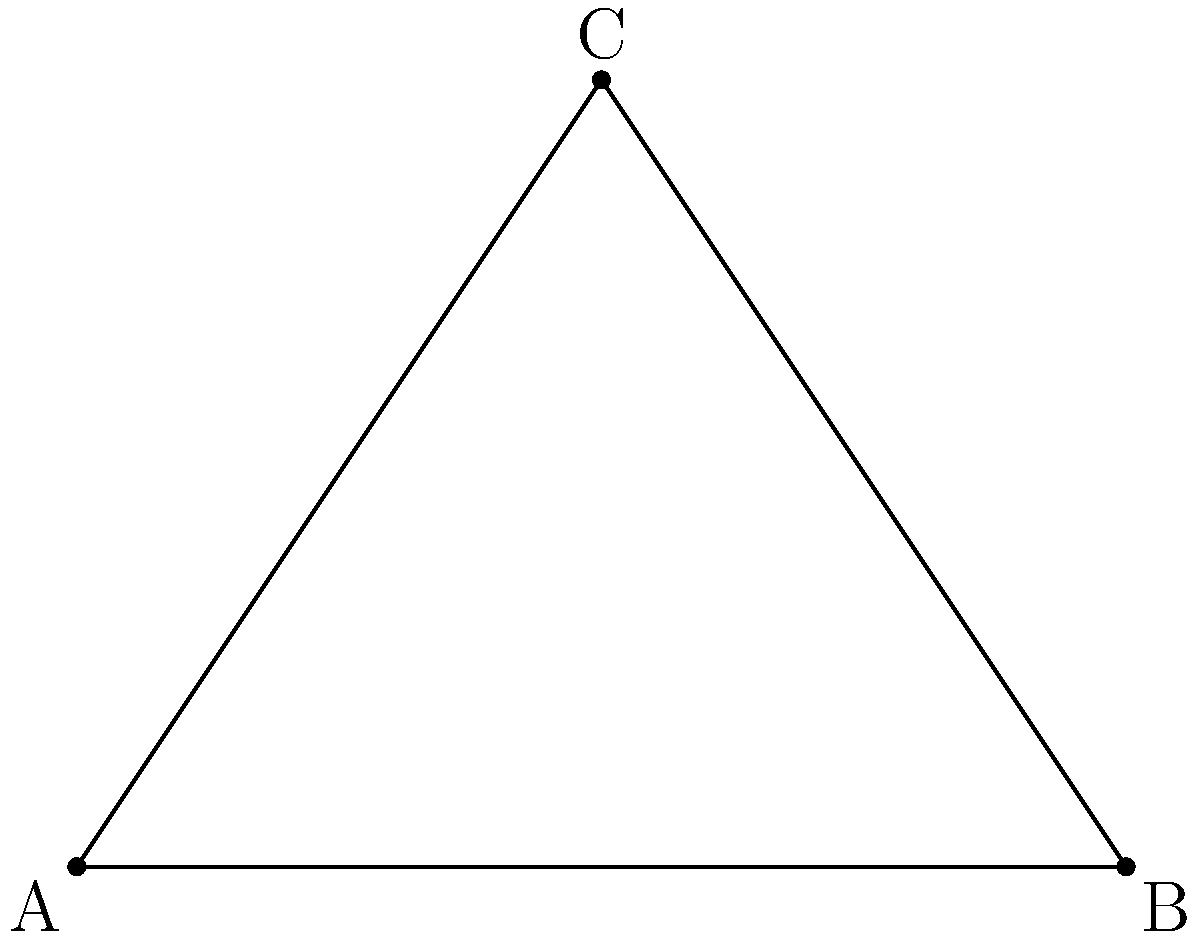As you prepare for your breakthrough concert at a triangular-shaped venue, you need to determine the optimal angle for your main speakers to project sound effectively. The venue's dimensions are represented in the diagram above. If the stage is located at point C and the speakers are positioned at point A, what is the angle (in degrees) at which the sound should be projected to reach point B? Let's approach this step-by-step:

1) The venue is represented by a right-angled triangle ABC, where:
   - A is the position of the speakers
   - C is the stage
   - B is the farthest point to be reached by the sound
   - The right angle is at C

2) We're given that:
   - The angle at A adjacent to AB is 30°
   - AC = 6 m
   - AB = 8 m

3) We need to find the angle CAB, which is the angle of sound projection.

4) In a right-angled triangle, the sum of all angles is 180°. We know that:
   - Angle ACB = 90° (given)
   - Angle BAC = 30° (given)

5) Let's call our target angle CAB = x°

6) Using the angle sum property of triangles:
   $$90° + 30° + x° = 180°$$
   $$120° + x° = 180°$$

7) Solving for x:
   $$x° = 180° - 120° = 60°$$

Therefore, the angle at which the sound should be projected is 60°.
Answer: 60° 